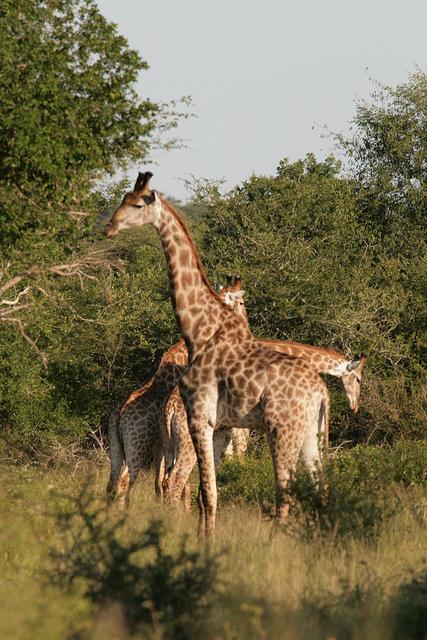Are the giraffes all facing the same direction?
Concise answer only. No. Are they in the wild?
Give a very brief answer. Yes. Are the giraffes in the zoo?
Keep it brief. No. 